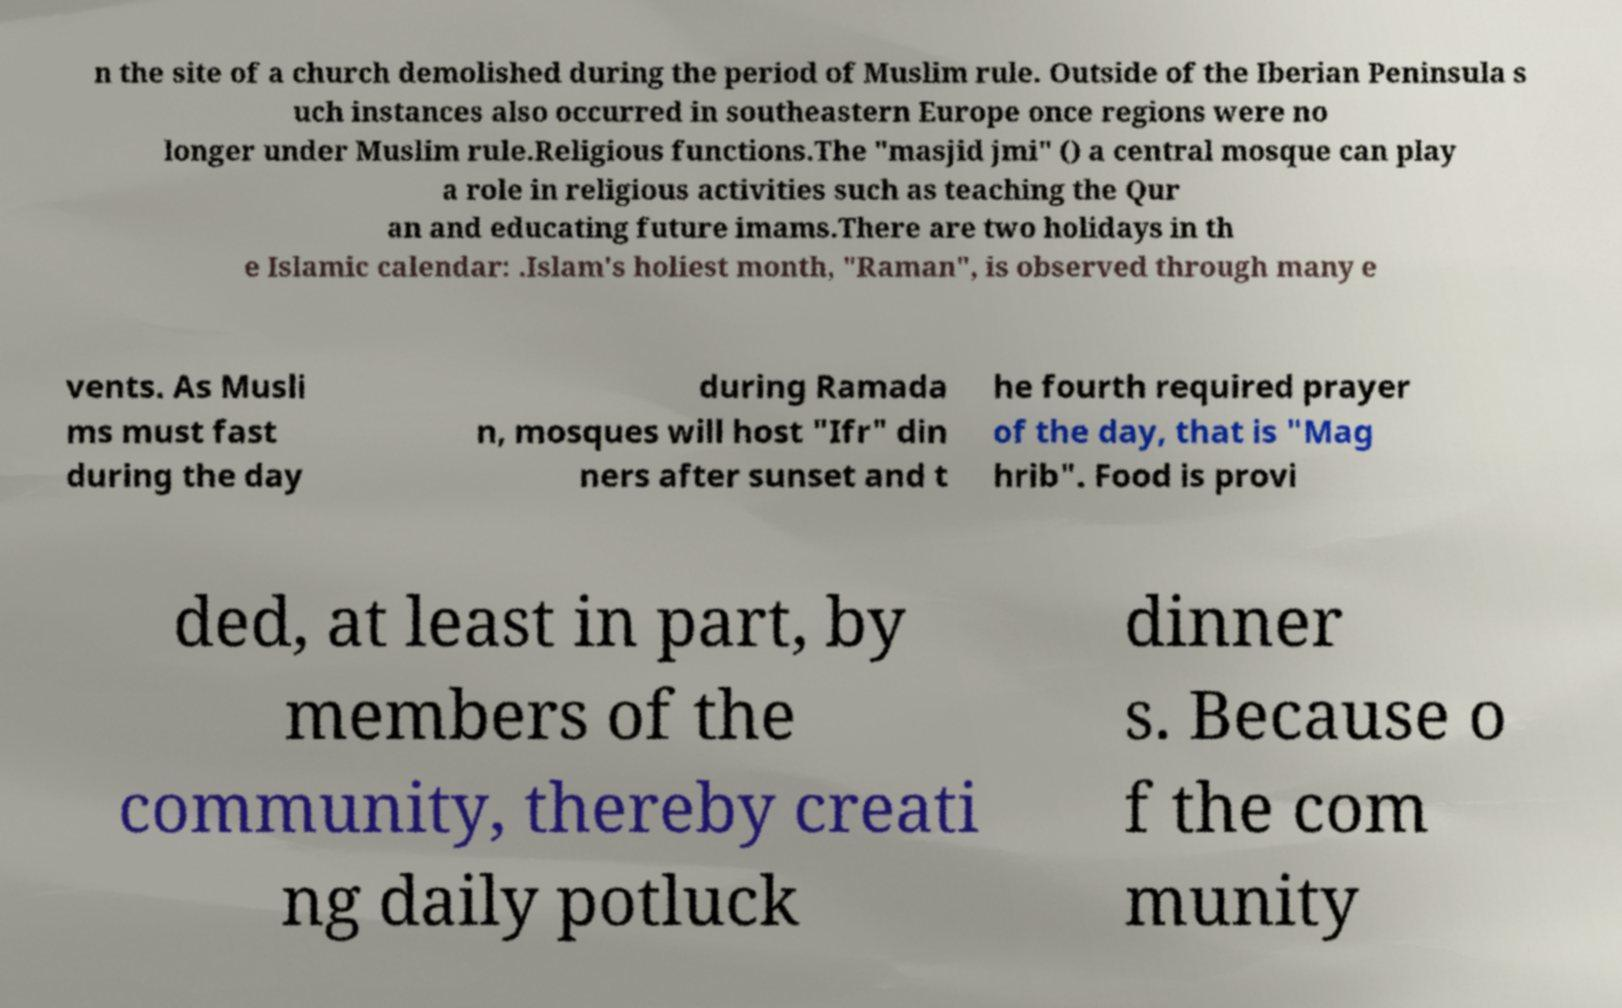Please identify and transcribe the text found in this image. n the site of a church demolished during the period of Muslim rule. Outside of the Iberian Peninsula s uch instances also occurred in southeastern Europe once regions were no longer under Muslim rule.Religious functions.The "masjid jmi" () a central mosque can play a role in religious activities such as teaching the Qur an and educating future imams.There are two holidays in th e Islamic calendar: .Islam's holiest month, "Raman", is observed through many e vents. As Musli ms must fast during the day during Ramada n, mosques will host "Ifr" din ners after sunset and t he fourth required prayer of the day, that is "Mag hrib". Food is provi ded, at least in part, by members of the community, thereby creati ng daily potluck dinner s. Because o f the com munity 